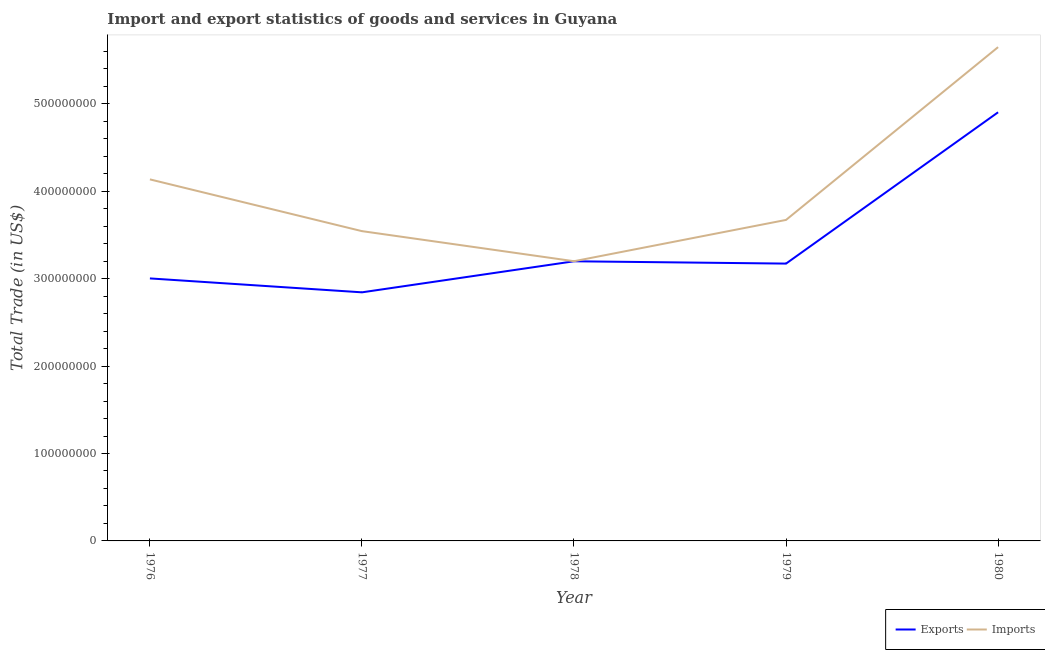How many different coloured lines are there?
Your answer should be very brief. 2. Does the line corresponding to export of goods and services intersect with the line corresponding to imports of goods and services?
Give a very brief answer. No. Is the number of lines equal to the number of legend labels?
Your response must be concise. Yes. What is the export of goods and services in 1980?
Provide a succinct answer. 4.90e+08. Across all years, what is the maximum export of goods and services?
Offer a very short reply. 4.90e+08. Across all years, what is the minimum export of goods and services?
Make the answer very short. 2.84e+08. In which year was the imports of goods and services maximum?
Your response must be concise. 1980. In which year was the imports of goods and services minimum?
Ensure brevity in your answer.  1978. What is the total imports of goods and services in the graph?
Offer a terse response. 2.02e+09. What is the difference between the imports of goods and services in 1979 and that in 1980?
Your answer should be very brief. -1.98e+08. What is the difference between the export of goods and services in 1980 and the imports of goods and services in 1976?
Provide a succinct answer. 7.68e+07. What is the average export of goods and services per year?
Provide a short and direct response. 3.42e+08. In the year 1980, what is the difference between the imports of goods and services and export of goods and services?
Ensure brevity in your answer.  7.45e+07. What is the ratio of the imports of goods and services in 1976 to that in 1980?
Offer a very short reply. 0.73. What is the difference between the highest and the second highest export of goods and services?
Offer a terse response. 1.70e+08. What is the difference between the highest and the lowest export of goods and services?
Your answer should be very brief. 2.06e+08. Is the imports of goods and services strictly greater than the export of goods and services over the years?
Ensure brevity in your answer.  Yes. Is the imports of goods and services strictly less than the export of goods and services over the years?
Keep it short and to the point. No. How many lines are there?
Offer a terse response. 2. How many years are there in the graph?
Your answer should be compact. 5. What is the difference between two consecutive major ticks on the Y-axis?
Give a very brief answer. 1.00e+08. Does the graph contain any zero values?
Give a very brief answer. No. Where does the legend appear in the graph?
Ensure brevity in your answer.  Bottom right. What is the title of the graph?
Give a very brief answer. Import and export statistics of goods and services in Guyana. What is the label or title of the Y-axis?
Offer a terse response. Total Trade (in US$). What is the Total Trade (in US$) in Exports in 1976?
Ensure brevity in your answer.  3.00e+08. What is the Total Trade (in US$) in Imports in 1976?
Provide a succinct answer. 4.14e+08. What is the Total Trade (in US$) of Exports in 1977?
Offer a terse response. 2.84e+08. What is the Total Trade (in US$) of Imports in 1977?
Provide a short and direct response. 3.54e+08. What is the Total Trade (in US$) of Exports in 1978?
Make the answer very short. 3.20e+08. What is the Total Trade (in US$) in Imports in 1978?
Ensure brevity in your answer.  3.20e+08. What is the Total Trade (in US$) in Exports in 1979?
Give a very brief answer. 3.17e+08. What is the Total Trade (in US$) in Imports in 1979?
Ensure brevity in your answer.  3.67e+08. What is the Total Trade (in US$) in Exports in 1980?
Offer a terse response. 4.90e+08. What is the Total Trade (in US$) in Imports in 1980?
Offer a very short reply. 5.65e+08. Across all years, what is the maximum Total Trade (in US$) of Exports?
Your response must be concise. 4.90e+08. Across all years, what is the maximum Total Trade (in US$) in Imports?
Offer a terse response. 5.65e+08. Across all years, what is the minimum Total Trade (in US$) of Exports?
Provide a succinct answer. 2.84e+08. Across all years, what is the minimum Total Trade (in US$) in Imports?
Keep it short and to the point. 3.20e+08. What is the total Total Trade (in US$) of Exports in the graph?
Make the answer very short. 1.71e+09. What is the total Total Trade (in US$) of Imports in the graph?
Keep it short and to the point. 2.02e+09. What is the difference between the Total Trade (in US$) in Exports in 1976 and that in 1977?
Provide a succinct answer. 1.59e+07. What is the difference between the Total Trade (in US$) in Imports in 1976 and that in 1977?
Offer a very short reply. 5.92e+07. What is the difference between the Total Trade (in US$) in Exports in 1976 and that in 1978?
Make the answer very short. -1.96e+07. What is the difference between the Total Trade (in US$) in Imports in 1976 and that in 1978?
Provide a succinct answer. 9.36e+07. What is the difference between the Total Trade (in US$) in Exports in 1976 and that in 1979?
Provide a succinct answer. -1.70e+07. What is the difference between the Total Trade (in US$) in Imports in 1976 and that in 1979?
Your answer should be very brief. 4.64e+07. What is the difference between the Total Trade (in US$) of Exports in 1976 and that in 1980?
Ensure brevity in your answer.  -1.90e+08. What is the difference between the Total Trade (in US$) of Imports in 1976 and that in 1980?
Your answer should be compact. -1.51e+08. What is the difference between the Total Trade (in US$) of Exports in 1977 and that in 1978?
Offer a terse response. -3.55e+07. What is the difference between the Total Trade (in US$) in Imports in 1977 and that in 1978?
Keep it short and to the point. 3.44e+07. What is the difference between the Total Trade (in US$) of Exports in 1977 and that in 1979?
Keep it short and to the point. -3.29e+07. What is the difference between the Total Trade (in US$) of Imports in 1977 and that in 1979?
Offer a terse response. -1.28e+07. What is the difference between the Total Trade (in US$) in Exports in 1977 and that in 1980?
Provide a succinct answer. -2.06e+08. What is the difference between the Total Trade (in US$) of Imports in 1977 and that in 1980?
Keep it short and to the point. -2.10e+08. What is the difference between the Total Trade (in US$) of Exports in 1978 and that in 1979?
Your answer should be very brief. 2.64e+06. What is the difference between the Total Trade (in US$) of Imports in 1978 and that in 1979?
Offer a very short reply. -4.72e+07. What is the difference between the Total Trade (in US$) of Exports in 1978 and that in 1980?
Offer a terse response. -1.70e+08. What is the difference between the Total Trade (in US$) of Imports in 1978 and that in 1980?
Offer a very short reply. -2.45e+08. What is the difference between the Total Trade (in US$) in Exports in 1979 and that in 1980?
Your answer should be very brief. -1.73e+08. What is the difference between the Total Trade (in US$) in Imports in 1979 and that in 1980?
Offer a terse response. -1.98e+08. What is the difference between the Total Trade (in US$) of Exports in 1976 and the Total Trade (in US$) of Imports in 1977?
Make the answer very short. -5.41e+07. What is the difference between the Total Trade (in US$) in Exports in 1976 and the Total Trade (in US$) in Imports in 1978?
Provide a short and direct response. -1.97e+07. What is the difference between the Total Trade (in US$) of Exports in 1976 and the Total Trade (in US$) of Imports in 1979?
Keep it short and to the point. -6.69e+07. What is the difference between the Total Trade (in US$) in Exports in 1976 and the Total Trade (in US$) in Imports in 1980?
Provide a succinct answer. -2.65e+08. What is the difference between the Total Trade (in US$) in Exports in 1977 and the Total Trade (in US$) in Imports in 1978?
Offer a terse response. -3.56e+07. What is the difference between the Total Trade (in US$) in Exports in 1977 and the Total Trade (in US$) in Imports in 1979?
Make the answer very short. -8.28e+07. What is the difference between the Total Trade (in US$) in Exports in 1977 and the Total Trade (in US$) in Imports in 1980?
Keep it short and to the point. -2.80e+08. What is the difference between the Total Trade (in US$) in Exports in 1978 and the Total Trade (in US$) in Imports in 1979?
Your answer should be compact. -4.73e+07. What is the difference between the Total Trade (in US$) of Exports in 1978 and the Total Trade (in US$) of Imports in 1980?
Keep it short and to the point. -2.45e+08. What is the difference between the Total Trade (in US$) of Exports in 1979 and the Total Trade (in US$) of Imports in 1980?
Give a very brief answer. -2.48e+08. What is the average Total Trade (in US$) in Exports per year?
Keep it short and to the point. 3.42e+08. What is the average Total Trade (in US$) of Imports per year?
Keep it short and to the point. 4.04e+08. In the year 1976, what is the difference between the Total Trade (in US$) in Exports and Total Trade (in US$) in Imports?
Offer a very short reply. -1.13e+08. In the year 1977, what is the difference between the Total Trade (in US$) of Exports and Total Trade (in US$) of Imports?
Offer a very short reply. -7.00e+07. In the year 1978, what is the difference between the Total Trade (in US$) of Exports and Total Trade (in US$) of Imports?
Your answer should be compact. -8.00e+04. In the year 1979, what is the difference between the Total Trade (in US$) of Exports and Total Trade (in US$) of Imports?
Ensure brevity in your answer.  -5.00e+07. In the year 1980, what is the difference between the Total Trade (in US$) in Exports and Total Trade (in US$) in Imports?
Your response must be concise. -7.45e+07. What is the ratio of the Total Trade (in US$) of Exports in 1976 to that in 1977?
Your response must be concise. 1.06. What is the ratio of the Total Trade (in US$) in Imports in 1976 to that in 1977?
Your answer should be very brief. 1.17. What is the ratio of the Total Trade (in US$) in Exports in 1976 to that in 1978?
Provide a succinct answer. 0.94. What is the ratio of the Total Trade (in US$) of Imports in 1976 to that in 1978?
Keep it short and to the point. 1.29. What is the ratio of the Total Trade (in US$) of Exports in 1976 to that in 1979?
Your response must be concise. 0.95. What is the ratio of the Total Trade (in US$) of Imports in 1976 to that in 1979?
Your answer should be compact. 1.13. What is the ratio of the Total Trade (in US$) in Exports in 1976 to that in 1980?
Your response must be concise. 0.61. What is the ratio of the Total Trade (in US$) in Imports in 1976 to that in 1980?
Make the answer very short. 0.73. What is the ratio of the Total Trade (in US$) of Exports in 1977 to that in 1978?
Provide a succinct answer. 0.89. What is the ratio of the Total Trade (in US$) in Imports in 1977 to that in 1978?
Offer a terse response. 1.11. What is the ratio of the Total Trade (in US$) of Exports in 1977 to that in 1979?
Offer a very short reply. 0.9. What is the ratio of the Total Trade (in US$) in Imports in 1977 to that in 1979?
Your answer should be compact. 0.96. What is the ratio of the Total Trade (in US$) of Exports in 1977 to that in 1980?
Your response must be concise. 0.58. What is the ratio of the Total Trade (in US$) in Imports in 1977 to that in 1980?
Your answer should be very brief. 0.63. What is the ratio of the Total Trade (in US$) in Exports in 1978 to that in 1979?
Your response must be concise. 1.01. What is the ratio of the Total Trade (in US$) of Imports in 1978 to that in 1979?
Your response must be concise. 0.87. What is the ratio of the Total Trade (in US$) in Exports in 1978 to that in 1980?
Offer a terse response. 0.65. What is the ratio of the Total Trade (in US$) in Imports in 1978 to that in 1980?
Ensure brevity in your answer.  0.57. What is the ratio of the Total Trade (in US$) in Exports in 1979 to that in 1980?
Keep it short and to the point. 0.65. What is the ratio of the Total Trade (in US$) of Imports in 1979 to that in 1980?
Provide a short and direct response. 0.65. What is the difference between the highest and the second highest Total Trade (in US$) in Exports?
Make the answer very short. 1.70e+08. What is the difference between the highest and the second highest Total Trade (in US$) in Imports?
Make the answer very short. 1.51e+08. What is the difference between the highest and the lowest Total Trade (in US$) of Exports?
Your response must be concise. 2.06e+08. What is the difference between the highest and the lowest Total Trade (in US$) of Imports?
Your answer should be compact. 2.45e+08. 